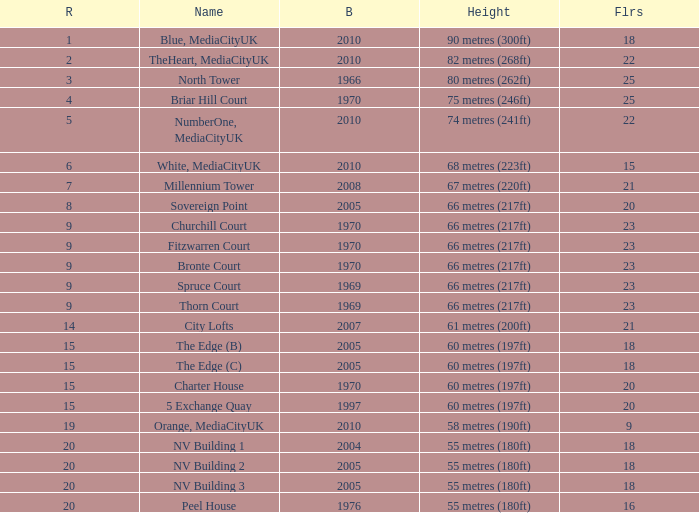What is the total number of Built, when Floors is less than 22, when Rank is less than 8, and when Name is White, Mediacityuk? 1.0. 